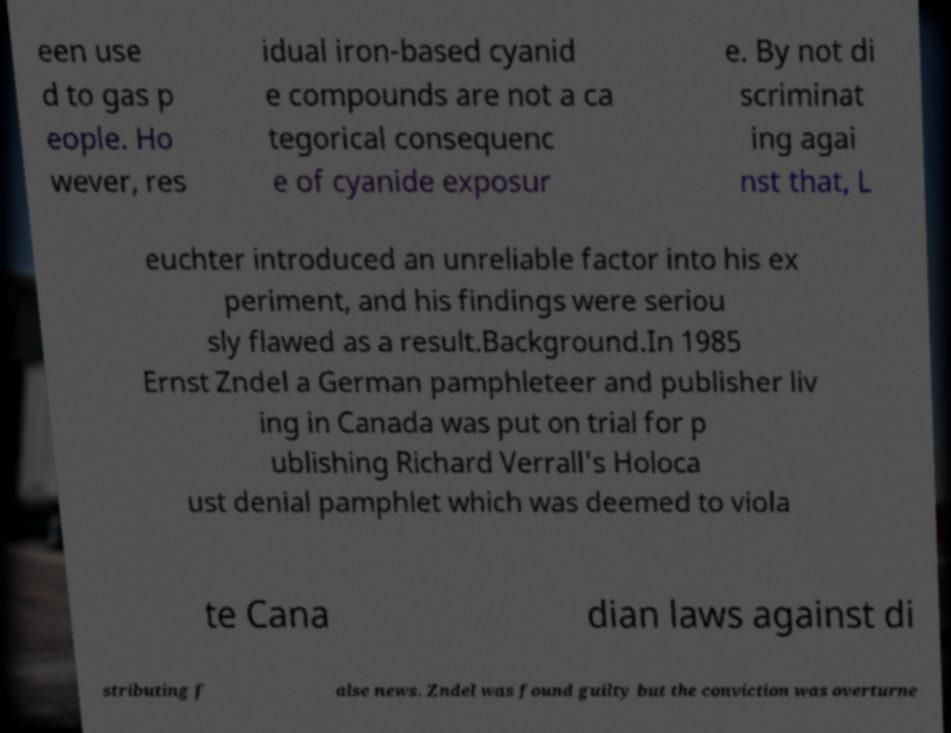Can you read and provide the text displayed in the image?This photo seems to have some interesting text. Can you extract and type it out for me? een use d to gas p eople. Ho wever, res idual iron-based cyanid e compounds are not a ca tegorical consequenc e of cyanide exposur e. By not di scriminat ing agai nst that, L euchter introduced an unreliable factor into his ex periment, and his findings were seriou sly flawed as a result.Background.In 1985 Ernst Zndel a German pamphleteer and publisher liv ing in Canada was put on trial for p ublishing Richard Verrall's Holoca ust denial pamphlet which was deemed to viola te Cana dian laws against di stributing f alse news. Zndel was found guilty but the conviction was overturne 